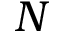Convert formula to latex. <formula><loc_0><loc_0><loc_500><loc_500>N</formula> 